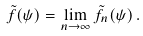Convert formula to latex. <formula><loc_0><loc_0><loc_500><loc_500>\tilde { f } ( \psi ) = \lim _ { n \to \infty } \tilde { f } _ { n } ( \psi ) \, .</formula> 